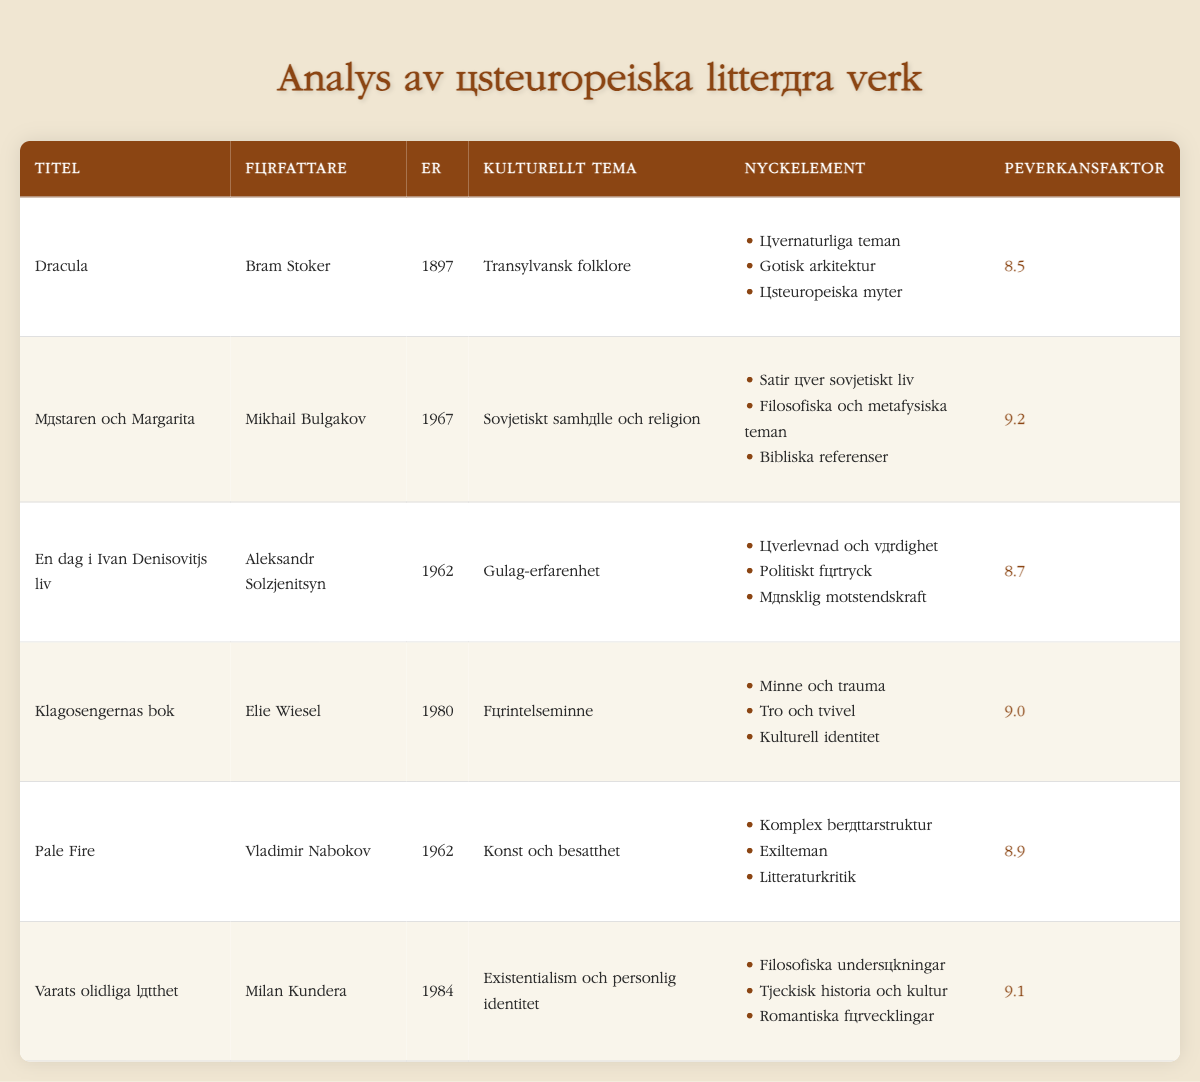What is the cultural theme of "The Master and Margarita"? The cultural theme of "The Master and Margarita," as specified in the table, is "Soviet society and religion."
Answer: Soviet society and religion Which author wrote "One Day in the Life of Ivan Denisovich"? The author listed for "One Day in the Life of Ivan Denisovich" in the table is Aleksandr Solzhenitsyn.
Answer: Aleksandr Solzhenitsyn What is the impact factor of "Pale Fire"? The impact factor for "Pale Fire" from the table is 8.9.
Answer: 8.9 What is the average impact factor of the literary works analyzed? To find the average, sum the impact factors (8.5 + 9.2 + 8.7 + 9.0 + 8.9 + 9.1 = 53.4), and then divide by the number of works (6). So, 53.4 / 6 = 8.9.
Answer: 8.9 Is "Dracula" focused on Eastern European folklore? Yes, "Dracula" is categorized under the cultural theme of "Transylvanian folklore," which is a part of Eastern European culture.
Answer: Yes Which literary work has the highest impact factor? "The Master and Margarita" has the highest impact factor at 9.2 among the listed works in the table.
Answer: The Master and Margarita What themes are present in "The Book of Lamentations"? The key elements listed for "The Book of Lamentations" include "Memory and trauma," "Faith and doubt," and "Cultural identity."
Answer: Memory and trauma, Faith and doubt, Cultural identity Which author has written both "Pale Fire" and "One Day in the Life of Ivan Denisovich"? No single author has written both "Pale Fire" and "One Day in the Life of Ivan Denisovich," as they were written by Vladimir Nabokov and Aleksandr Solzhenitsyn, respectively.
Answer: No What is the difference in impact factors between "The Unbearable Lightness of Being" and "The Book of Lamentations"? To find this difference, subtract the impact factor of "The Book of Lamentations" (9.0) from that of "The Unbearable Lightness of Being" (9.1). So, 9.1 - 9.0 = 0.1.
Answer: 0.1 